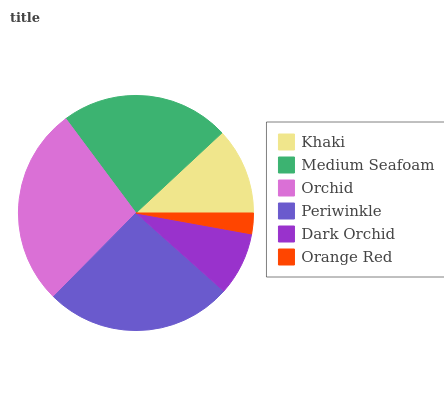Is Orange Red the minimum?
Answer yes or no. Yes. Is Orchid the maximum?
Answer yes or no. Yes. Is Medium Seafoam the minimum?
Answer yes or no. No. Is Medium Seafoam the maximum?
Answer yes or no. No. Is Medium Seafoam greater than Khaki?
Answer yes or no. Yes. Is Khaki less than Medium Seafoam?
Answer yes or no. Yes. Is Khaki greater than Medium Seafoam?
Answer yes or no. No. Is Medium Seafoam less than Khaki?
Answer yes or no. No. Is Medium Seafoam the high median?
Answer yes or no. Yes. Is Khaki the low median?
Answer yes or no. Yes. Is Orchid the high median?
Answer yes or no. No. Is Orchid the low median?
Answer yes or no. No. 